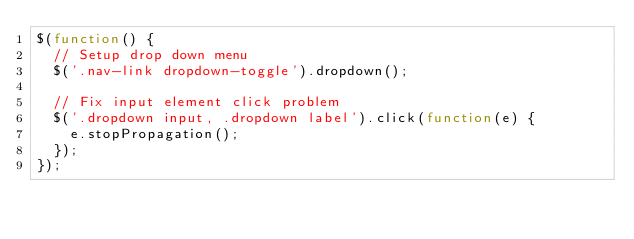Convert code to text. <code><loc_0><loc_0><loc_500><loc_500><_JavaScript_>$(function() {
  // Setup drop down menu
  $('.nav-link dropdown-toggle').dropdown();

  // Fix input element click problem
  $('.dropdown input, .dropdown label').click(function(e) {
    e.stopPropagation();
  });
});
</code> 